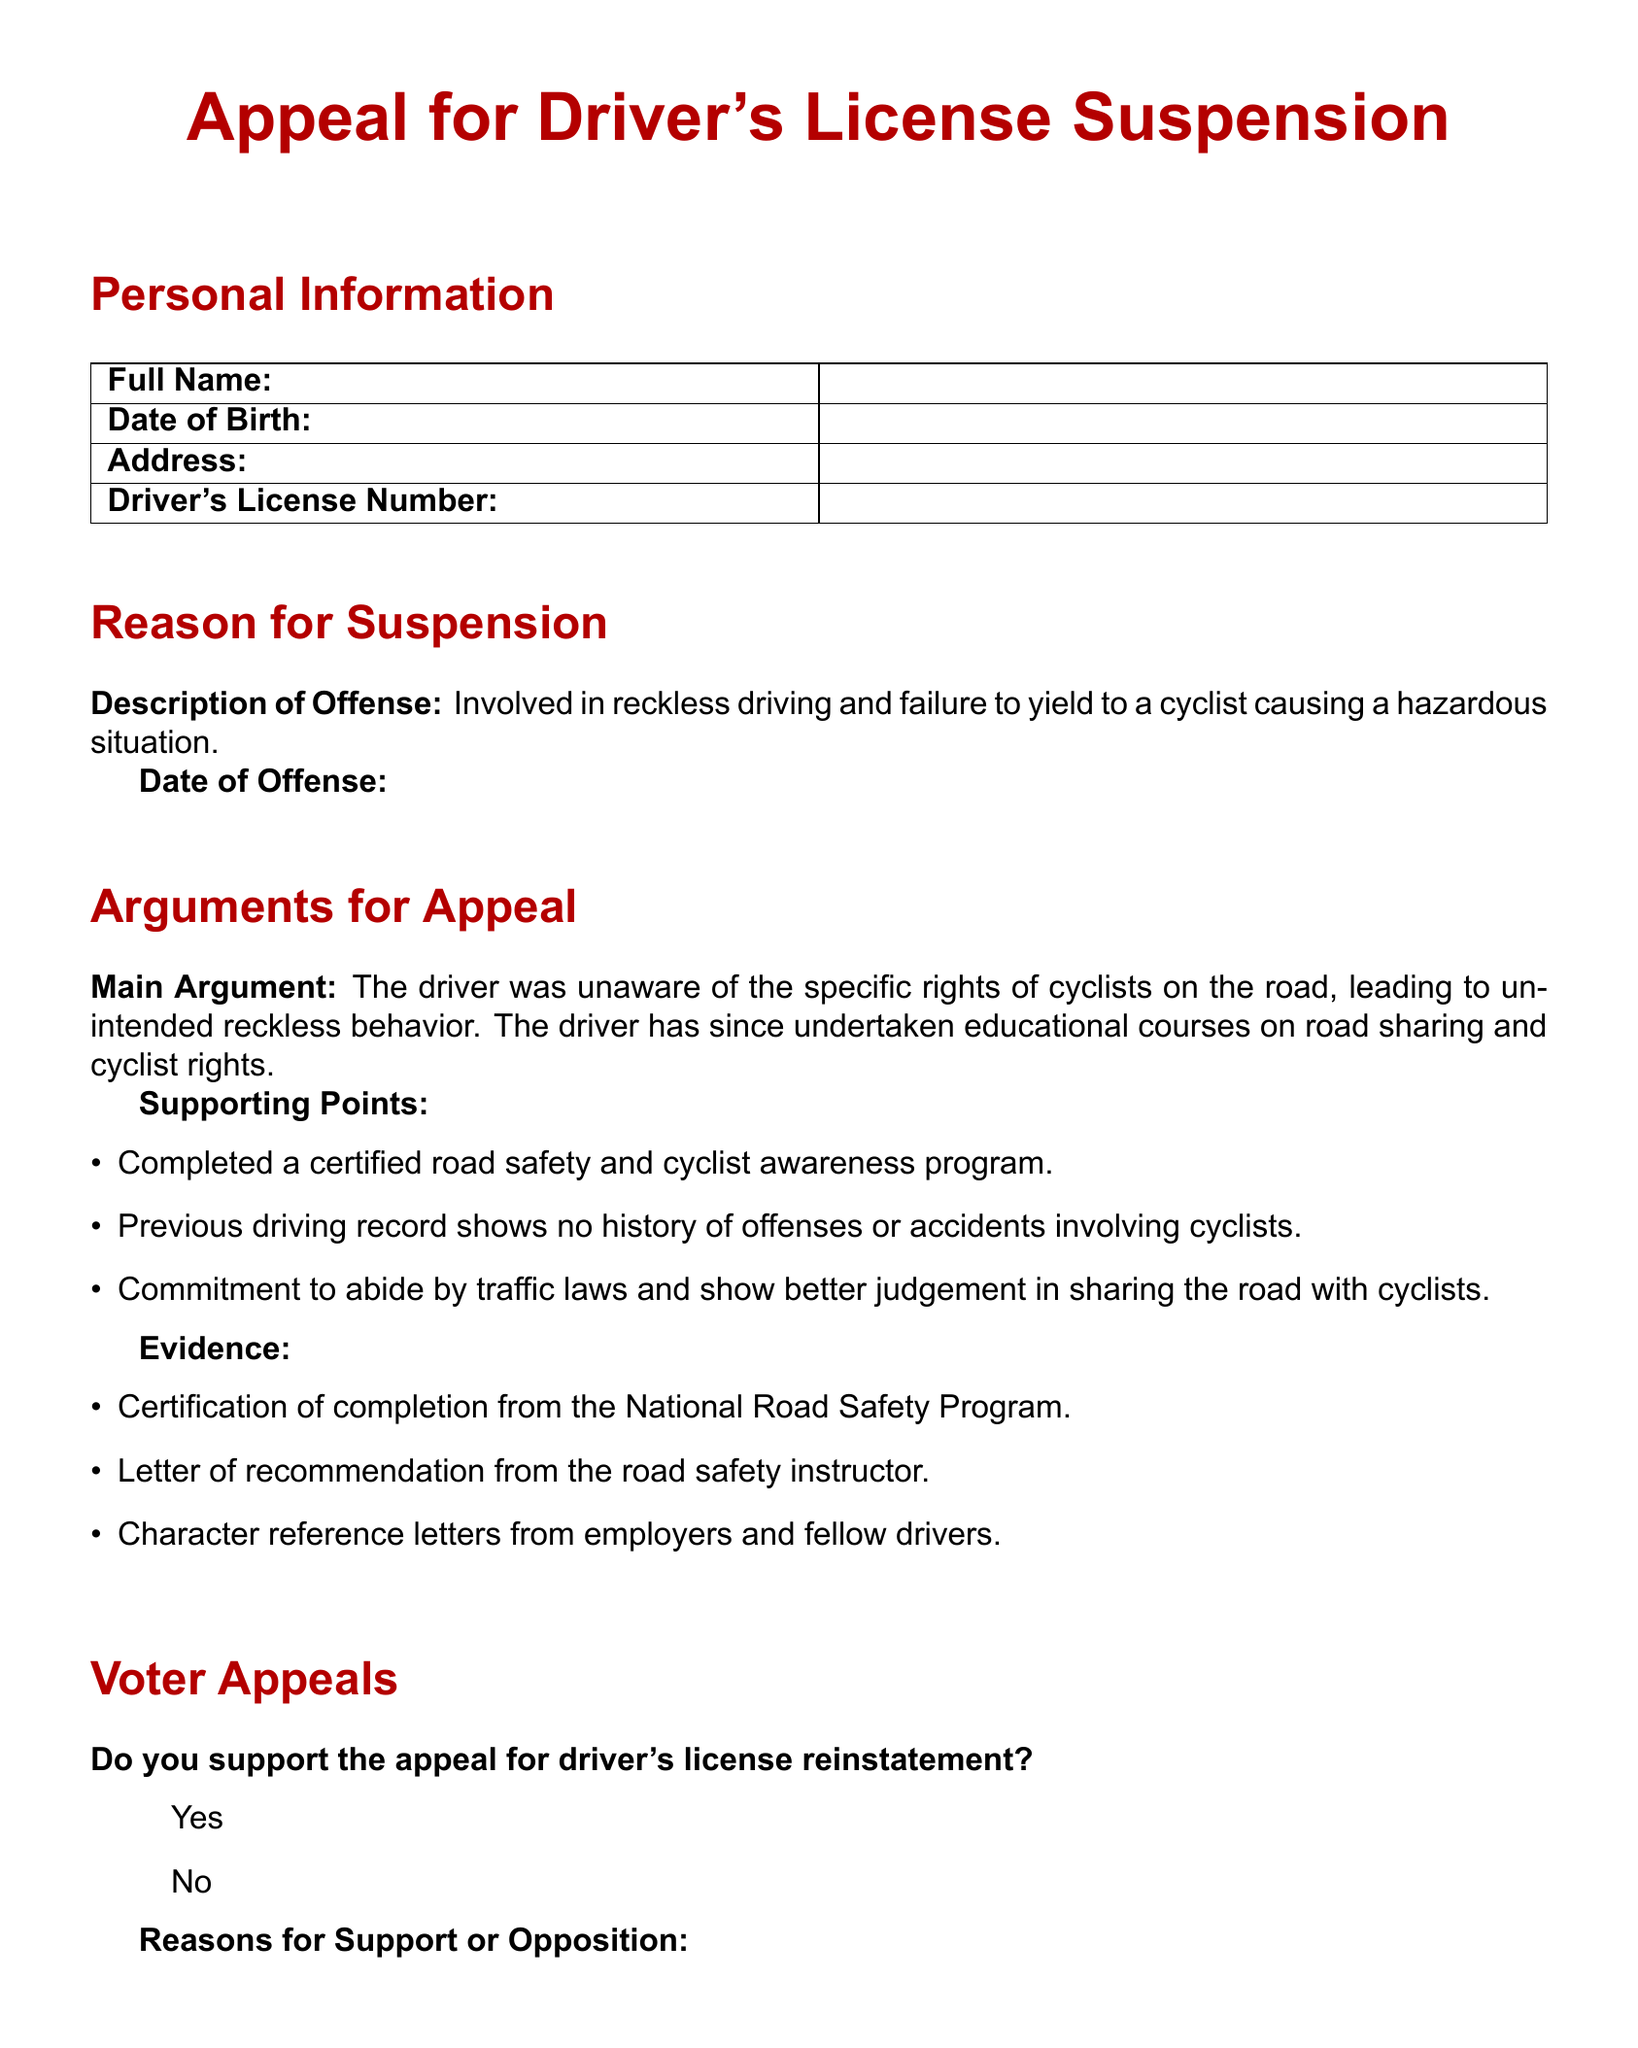What is the title of the document? The title of the document is indicated in large text at the top.
Answer: Appeal for Driver's License Suspension Who is the appellant? The appellant's full name is to be filled in the personal information section.
Answer: [Not provided] What was the description of the offense? The description of the offense details the reckless driving incident and its impact.
Answer: Involved in reckless driving and failure to yield to a cyclist causing a hazardous situation What is the date of birth format required? The format for the date of birth is typically month/day/year, but it's not explicitly stated.
Answer: [Not provided] What type of program has the driver completed? The driver completed a program to improve road safety and awareness.
Answer: certified road safety and cyclist awareness program What evidence supports the appeal? Evidence is laid out in a bulleted list, detailing various documents supporting the appeal.
Answer: Certification of completion from the National Road Safety Program What question is asked regarding voter support? The document includes a question that seeks to gauge voter support for the appeal.
Answer: Do you support the appeal for driver's license reinstatement? How many arguments are listed in the supporting points? The supporting points section contains three specific points.
Answer: 3 What two items are included in the signature section? The signature section requests two pieces of information from the appellant.
Answer: Appellant's Signature and Date 